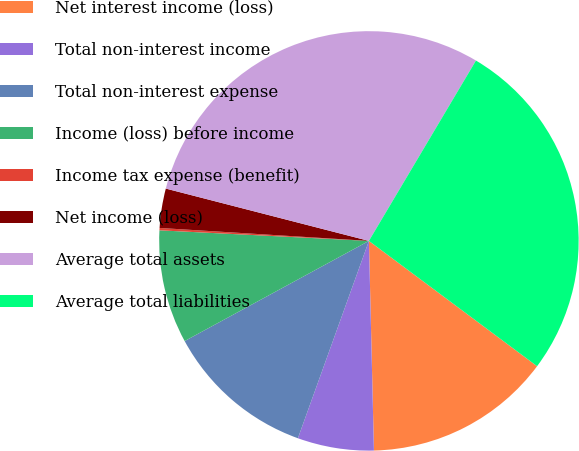Convert chart to OTSL. <chart><loc_0><loc_0><loc_500><loc_500><pie_chart><fcel>Net interest income (loss)<fcel>Total non-interest income<fcel>Total non-interest expense<fcel>Income (loss) before income<fcel>Income tax expense (benefit)<fcel>Net income (loss)<fcel>Average total assets<fcel>Average total liabilities<nl><fcel>14.43%<fcel>5.88%<fcel>11.58%<fcel>8.73%<fcel>0.18%<fcel>3.03%<fcel>29.52%<fcel>26.67%<nl></chart> 